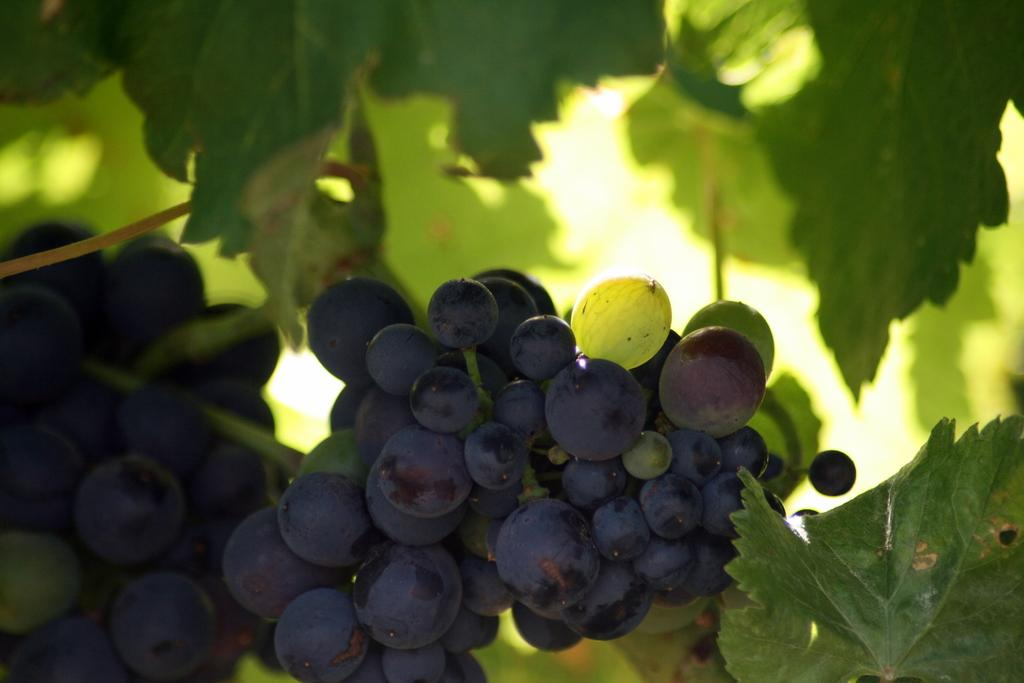Where was the image taken? The image was taken outdoors. What can be seen in the image besides the outdoor setting? There is a plant in the image. Can you describe the plant in the image? The plant has leaves, stems, and grapes. What color are the grapes on the plant? The grapes are black in color. Is there any smoke coming from the plant in the image? No, there is no smoke present in the image. What desire does the plant in the image fulfill? The plant in the image does not fulfill any desires, as it is an inanimate object. 